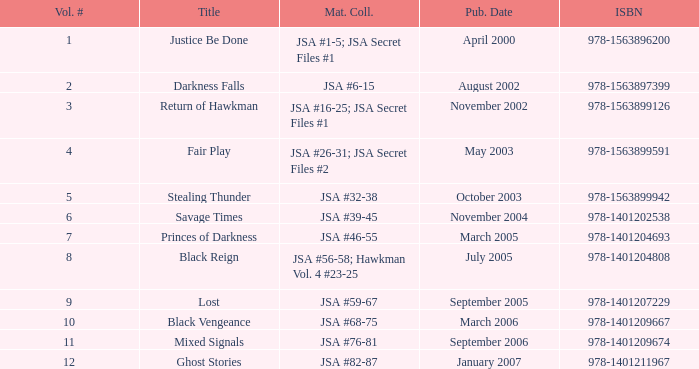What's the Material collected for the 978-1401209674 ISBN? JSA #76-81. 